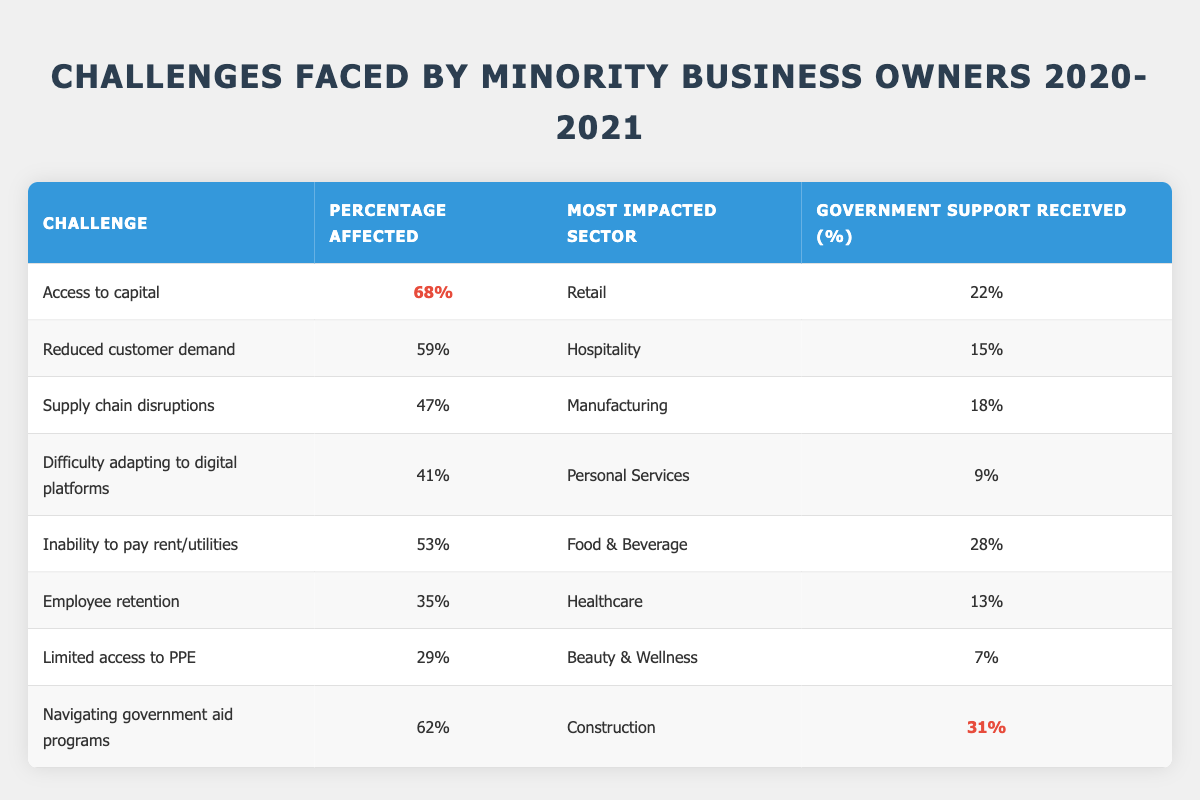What percentage of minority business owners reported access to capital as a challenge? The table lists "Access to capital" with a percentage affected of 68%. Therefore, 68% of minority business owners reported this as a challenge.
Answer: 68% Which sector was most impacted by reduced customer demand? According to the table, "Reduced customer demand" affected the Hospitality sector the most, as indicated in the corresponding row.
Answer: Hospitality How many challenges had a percentage affected over 50%? By inspecting the table, we find three challenges with percentages affected over 50%: Access to capital (68%), Reduced customer demand (59%), and Inability to pay rent/utilities (53%). Thus, the total is 3.
Answer: 3 What was the average percentage of government support received by the sectors listed? To calculate the average, we sum the percentages of government support received: 22 + 15 + 18 + 9 + 28 + 13 + 7 + 31 = 143. Since there are 8 sectors, the average is 143/8 = 17.875, which rounds to approximately 17.88%.
Answer: Approximately 17.88% Is it true that the "Beauty & Wellness" sector had the least percentage affected by limited access to PPE? The table shows "Limited access to PPE" had a percentage affected of 29% for the Beauty & Wellness sector, which is lower than the percentage affected by other sectors. Thus, it is true that it had one of the least affected percentages.
Answer: Yes Which challenge had the highest percentage of government support received? Looking at the table, "Navigating government aid programs" had the highest percentage of government support received at 31%.
Answer: 31% 